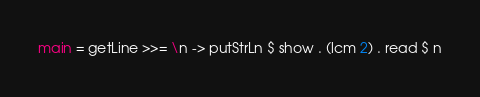<code> <loc_0><loc_0><loc_500><loc_500><_Haskell_>main = getLine >>= \n -> putStrLn $ show . (lcm 2) . read $ n
</code> 